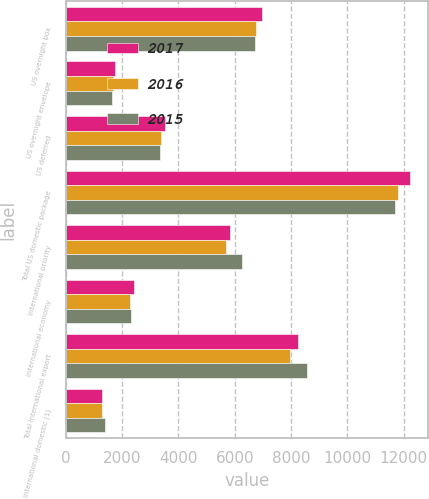<chart> <loc_0><loc_0><loc_500><loc_500><stacked_bar_chart><ecel><fcel>US overnight box<fcel>US overnight envelope<fcel>US deferred<fcel>Total US domestic package<fcel>International priority<fcel>International economy<fcel>Total international export<fcel>International domestic (1)<nl><fcel>2017<fcel>6958<fcel>1750<fcel>3528<fcel>12236<fcel>5827<fcel>2412<fcel>8239<fcel>1299<nl><fcel>2016<fcel>6763<fcel>1662<fcel>3379<fcel>11804<fcel>5697<fcel>2282<fcel>7979<fcel>1285<nl><fcel>2015<fcel>6704<fcel>1629<fcel>3342<fcel>11675<fcel>6251<fcel>2301<fcel>8552<fcel>1406<nl></chart> 